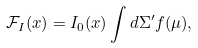Convert formula to latex. <formula><loc_0><loc_0><loc_500><loc_500>\mathcal { F } _ { I } ( x ) = I _ { 0 } ( x ) \int d \Sigma ^ { \prime } f ( \mu ) ,</formula> 